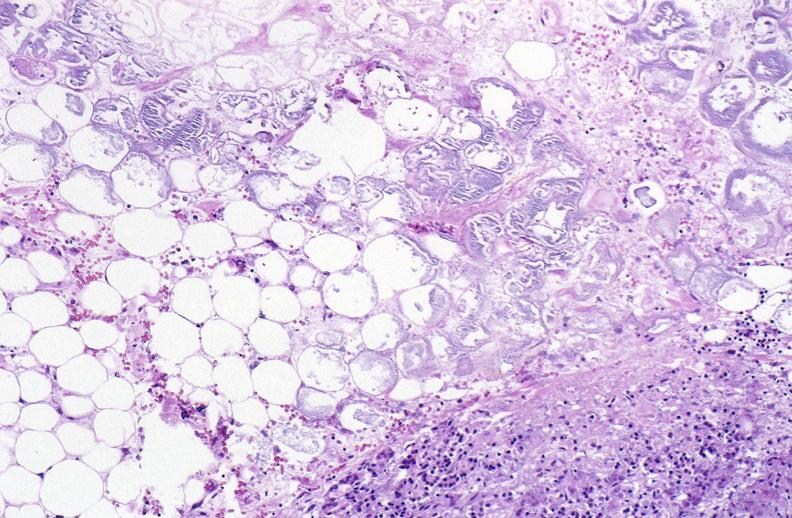what does this image show?
Answer the question using a single word or phrase. Pancreatic fat necrosis 